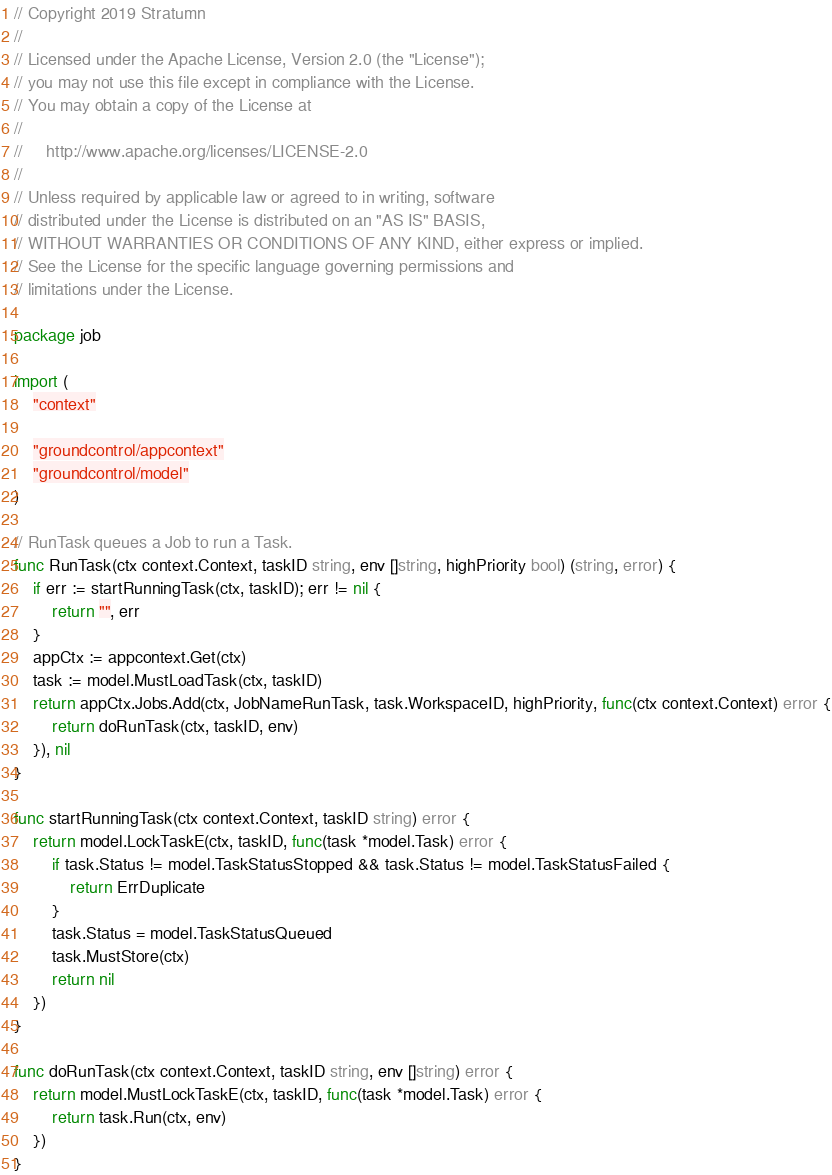Convert code to text. <code><loc_0><loc_0><loc_500><loc_500><_Go_>// Copyright 2019 Stratumn
//
// Licensed under the Apache License, Version 2.0 (the "License");
// you may not use this file except in compliance with the License.
// You may obtain a copy of the License at
//
//     http://www.apache.org/licenses/LICENSE-2.0
//
// Unless required by applicable law or agreed to in writing, software
// distributed under the License is distributed on an "AS IS" BASIS,
// WITHOUT WARRANTIES OR CONDITIONS OF ANY KIND, either express or implied.
// See the License for the specific language governing permissions and
// limitations under the License.

package job

import (
	"context"

	"groundcontrol/appcontext"
	"groundcontrol/model"
)

// RunTask queues a Job to run a Task.
func RunTask(ctx context.Context, taskID string, env []string, highPriority bool) (string, error) {
	if err := startRunningTask(ctx, taskID); err != nil {
		return "", err
	}
	appCtx := appcontext.Get(ctx)
	task := model.MustLoadTask(ctx, taskID)
	return appCtx.Jobs.Add(ctx, JobNameRunTask, task.WorkspaceID, highPriority, func(ctx context.Context) error {
		return doRunTask(ctx, taskID, env)
	}), nil
}

func startRunningTask(ctx context.Context, taskID string) error {
	return model.LockTaskE(ctx, taskID, func(task *model.Task) error {
		if task.Status != model.TaskStatusStopped && task.Status != model.TaskStatusFailed {
			return ErrDuplicate
		}
		task.Status = model.TaskStatusQueued
		task.MustStore(ctx)
		return nil
	})
}

func doRunTask(ctx context.Context, taskID string, env []string) error {
	return model.MustLockTaskE(ctx, taskID, func(task *model.Task) error {
		return task.Run(ctx, env)
	})
}
</code> 